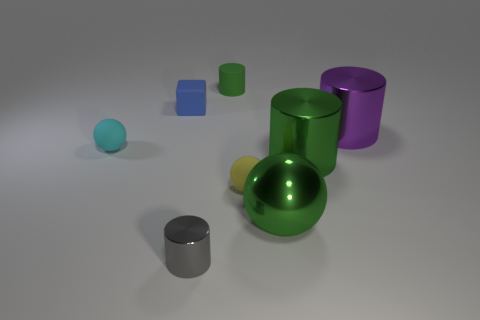Is there another cylinder that has the same color as the small shiny cylinder? Yes, there is indeed another cylinder sharing the same color as the small shiny one. Both cylinders exhibit a similar metallic sheen and hue, suggesting they are made from the same material or coated with the same finish. 